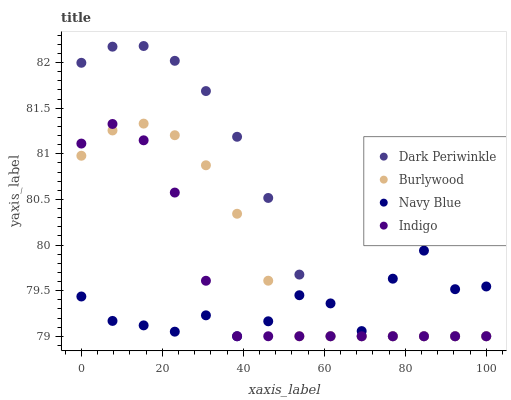Does Navy Blue have the minimum area under the curve?
Answer yes or no. Yes. Does Dark Periwinkle have the maximum area under the curve?
Answer yes or no. Yes. Does Indigo have the minimum area under the curve?
Answer yes or no. No. Does Indigo have the maximum area under the curve?
Answer yes or no. No. Is Burlywood the smoothest?
Answer yes or no. Yes. Is Navy Blue the roughest?
Answer yes or no. Yes. Is Indigo the smoothest?
Answer yes or no. No. Is Indigo the roughest?
Answer yes or no. No. Does Burlywood have the lowest value?
Answer yes or no. Yes. Does Dark Periwinkle have the highest value?
Answer yes or no. Yes. Does Indigo have the highest value?
Answer yes or no. No. Does Dark Periwinkle intersect Indigo?
Answer yes or no. Yes. Is Dark Periwinkle less than Indigo?
Answer yes or no. No. Is Dark Periwinkle greater than Indigo?
Answer yes or no. No. 